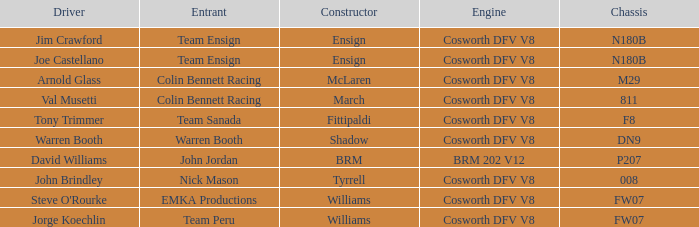Who built the Jim Crawford car? Ensign. 